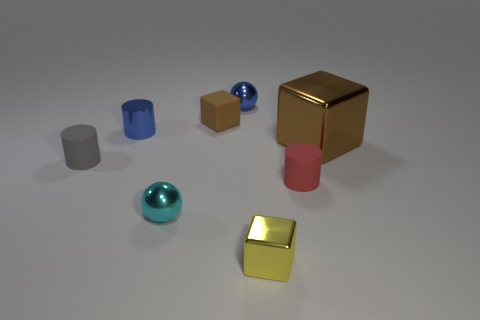Add 2 yellow rubber cylinders. How many objects exist? 10 Subtract all small shiny blocks. How many blocks are left? 2 Add 6 gray rubber objects. How many gray rubber objects exist? 7 Subtract all gray cylinders. How many cylinders are left? 2 Subtract 0 gray cubes. How many objects are left? 8 Subtract all balls. How many objects are left? 6 Subtract 1 spheres. How many spheres are left? 1 Subtract all purple blocks. Subtract all brown spheres. How many blocks are left? 3 Subtract all brown spheres. How many cyan cubes are left? 0 Subtract all large yellow things. Subtract all blue metal balls. How many objects are left? 7 